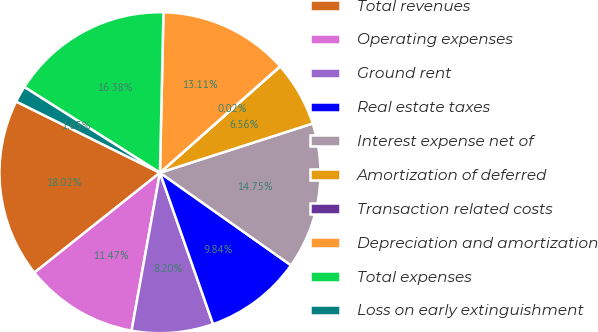<chart> <loc_0><loc_0><loc_500><loc_500><pie_chart><fcel>Total revenues<fcel>Operating expenses<fcel>Ground rent<fcel>Real estate taxes<fcel>Interest expense net of<fcel>Amortization of deferred<fcel>Transaction related costs<fcel>Depreciation and amortization<fcel>Total expenses<fcel>Loss on early extinguishment<nl><fcel>18.02%<fcel>11.47%<fcel>8.2%<fcel>9.84%<fcel>14.75%<fcel>6.56%<fcel>0.02%<fcel>13.11%<fcel>16.38%<fcel>1.65%<nl></chart> 